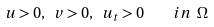Convert formula to latex. <formula><loc_0><loc_0><loc_500><loc_500>u > 0 , \ v > 0 , \ u _ { t } > 0 \quad i n \ \Omega</formula> 